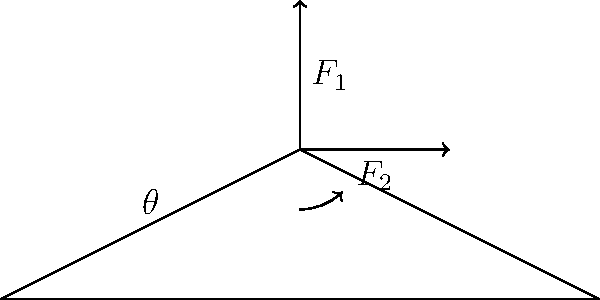A simple bridge truss is shown in the diagram above. The truss experiences two forces: a vertical force $F_1$ and a horizontal force $F_2$. The angle between the upper beam and the horizontal is denoted as $\theta$. If $F_1 = 100$ kN and $F_2 = 50$ kN, what is the optimal angle $\theta$ (in degrees) that minimizes the total stress on the truss? To find the optimal angle that minimizes the total stress on the truss, we need to follow these steps:

1. Decompose the forces into their components along the upper beam of the truss.

2. The force along the beam is given by:
   $$F_{beam} = F_1 \sin\theta + F_2 \cos\theta$$

3. To minimize the stress, we need to minimize $F_{beam}$. This occurs when the derivative of $F_{beam}$ with respect to $\theta$ is zero:
   $$\frac{d}{d\theta}F_{beam} = F_1 \cos\theta - F_2 \sin\theta = 0$$

4. Solving this equation:
   $$F_1 \cos\theta = F_2 \sin\theta$$
   $$\frac{F_1}{F_2} = \frac{\sin\theta}{\cos\theta} = \tan\theta$$

5. Therefore, the optimal angle is:
   $$\theta = \arctan(\frac{F_1}{F_2})$$

6. Substituting the given values:
   $$\theta = \arctan(\frac{100}{50}) = \arctan(2)$$

7. Converting to degrees:
   $$\theta = \arctan(2) \cdot \frac{180}{\pi} \approx 63.4°$$

Thus, the optimal angle that minimizes the total stress on the truss is approximately 63.4°.
Answer: 63.4° 